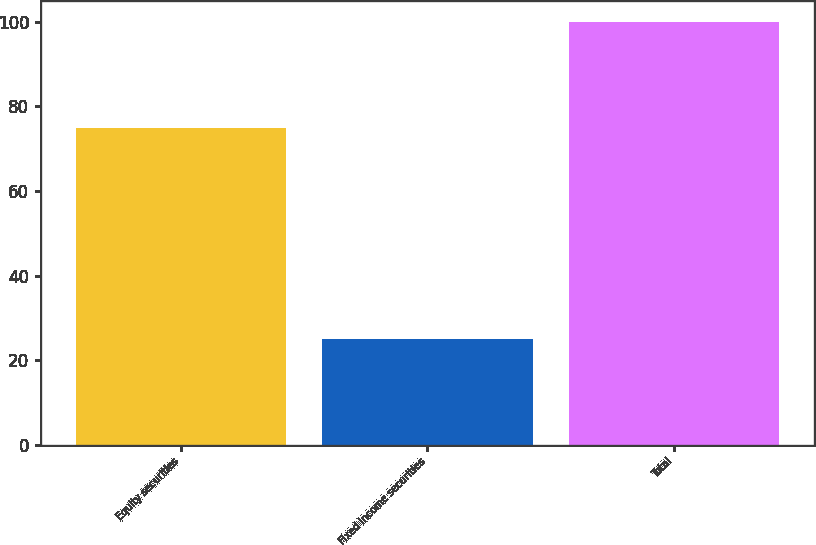<chart> <loc_0><loc_0><loc_500><loc_500><bar_chart><fcel>Equity securities<fcel>Fixed income securities<fcel>Total<nl><fcel>75<fcel>25<fcel>100<nl></chart> 